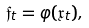<formula> <loc_0><loc_0><loc_500><loc_500>\mathfrak { f } _ { t } = \varphi ( \mathfrak { x } _ { t } ) ,</formula> 